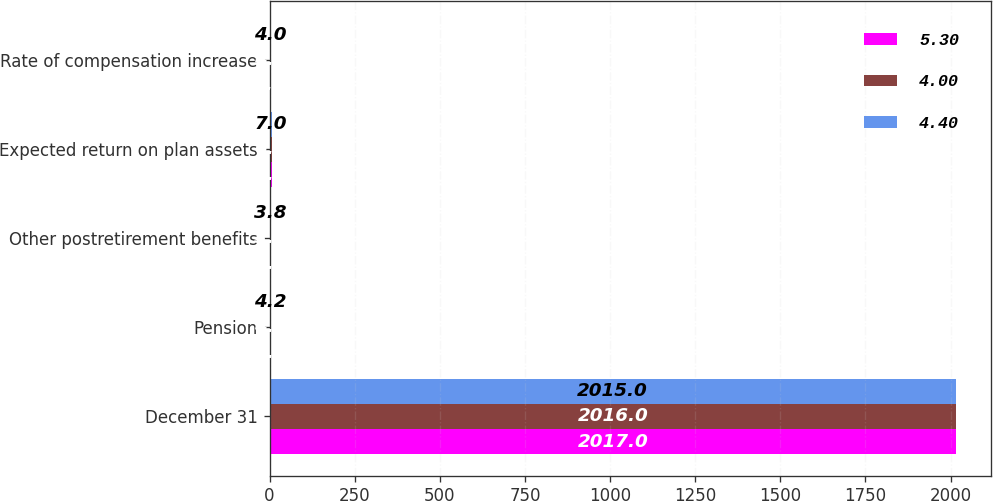Convert chart to OTSL. <chart><loc_0><loc_0><loc_500><loc_500><stacked_bar_chart><ecel><fcel>December 31<fcel>Pension<fcel>Other postretirement benefits<fcel>Expected return on plan assets<fcel>Rate of compensation increase<nl><fcel>5.3<fcel>2017<fcel>3.6<fcel>3.3<fcel>6.8<fcel>5.3<nl><fcel>4<fcel>2016<fcel>4<fcel>3.7<fcel>6.8<fcel>4.4<nl><fcel>4.4<fcel>2015<fcel>4.2<fcel>3.8<fcel>7<fcel>4<nl></chart> 